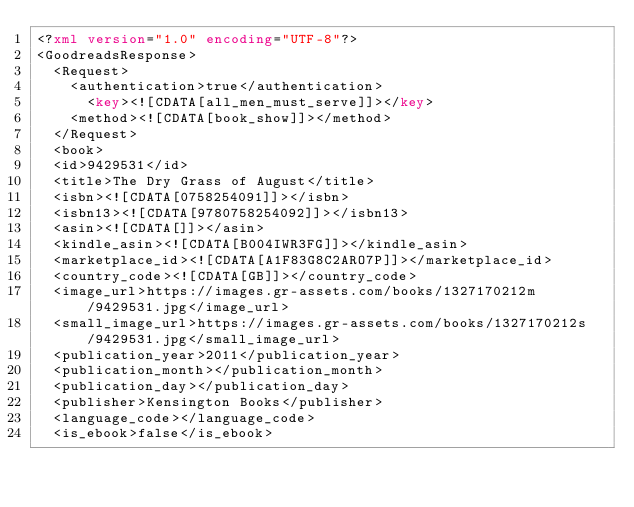<code> <loc_0><loc_0><loc_500><loc_500><_XML_><?xml version="1.0" encoding="UTF-8"?>
<GoodreadsResponse>
  <Request>
    <authentication>true</authentication>
      <key><![CDATA[all_men_must_serve]]></key>
    <method><![CDATA[book_show]]></method>
  </Request>
  <book>
  <id>9429531</id>
  <title>The Dry Grass of August</title>
  <isbn><![CDATA[0758254091]]></isbn>
  <isbn13><![CDATA[9780758254092]]></isbn13>
  <asin><![CDATA[]]></asin>
  <kindle_asin><![CDATA[B004IWR3FG]]></kindle_asin>
  <marketplace_id><![CDATA[A1F83G8C2ARO7P]]></marketplace_id>
  <country_code><![CDATA[GB]]></country_code>
  <image_url>https://images.gr-assets.com/books/1327170212m/9429531.jpg</image_url>
  <small_image_url>https://images.gr-assets.com/books/1327170212s/9429531.jpg</small_image_url>
  <publication_year>2011</publication_year>
  <publication_month></publication_month>
  <publication_day></publication_day>
  <publisher>Kensington Books</publisher>
  <language_code></language_code>
  <is_ebook>false</is_ebook></code> 